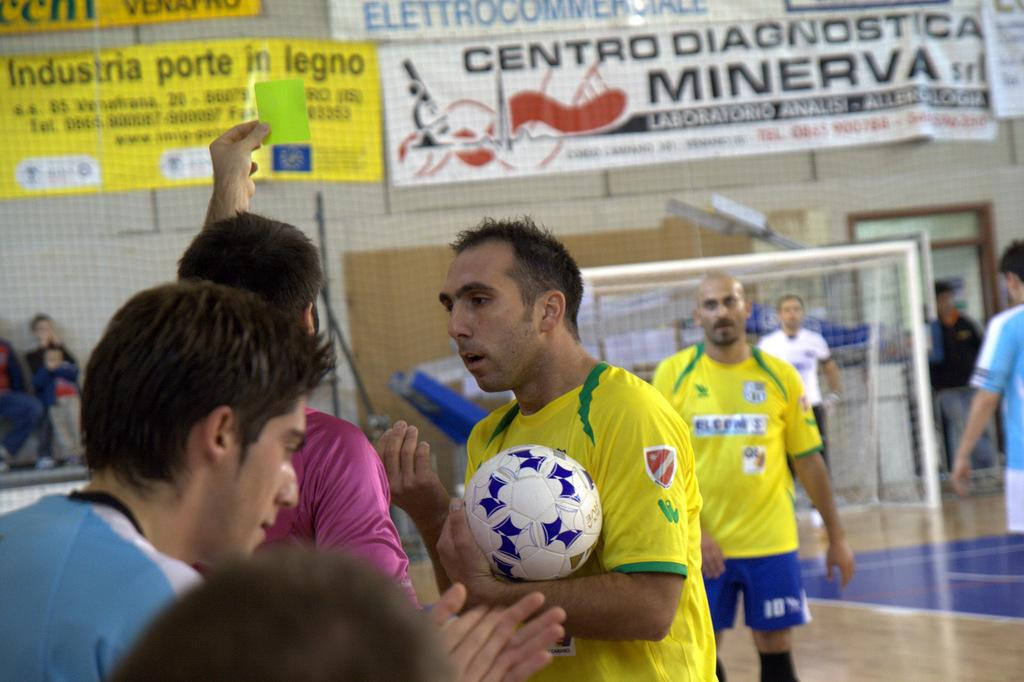How many people are in the image? There is a group of people in the image, but the exact number is not specified. What are the people doing in the image? The people are standing on the floor. What can be seen in the background of the image? There is a net in the background of the image. What object is being held by one of the people? A person is holding a ball in the image. Are there any cherries being served in the lunchroom in the image? There is no mention of a lunchroom or cherries in the image. The image features a group of people standing on the floor with a net in the background and a person holding a ball. 